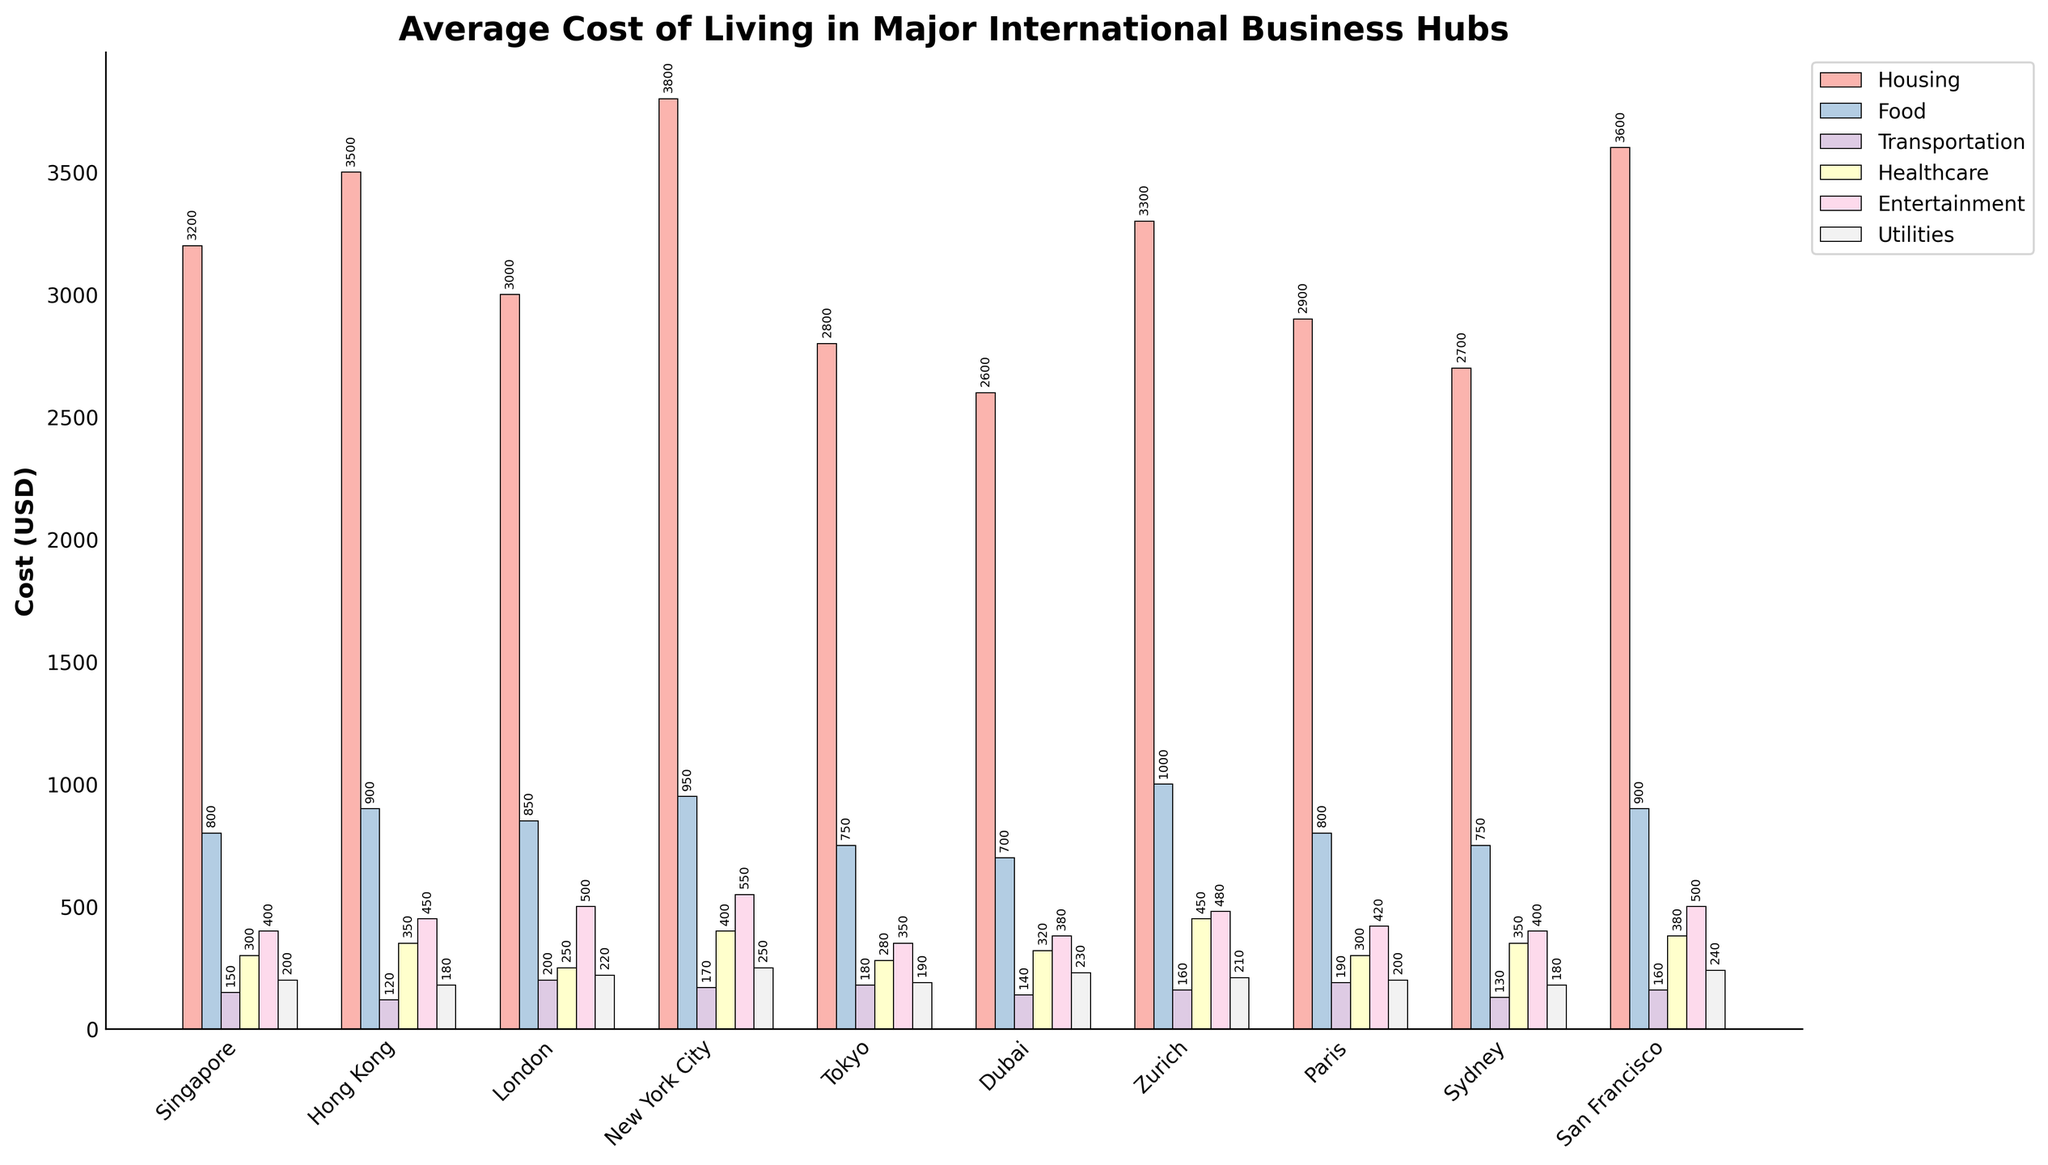Which city has the highest overall cost of living? To find the city with the highest overall cost of living, add up all expense categories for each city and compare the totals. New York City has the highest individual expenses, indicating it likely has the highest overall cost.
Answer: New York City Which two cities have the smallest difference in healthcare costs, and what is the difference? Compare the healthcare costs of all cities to find the smallest difference. Singapore ($300) and Paris ($300) both have the same healthcare cost, resulting in a difference of $0.
Answer: Singapore and Paris; $0 What is the total housing cost for the three most expensive cities in terms of housing? Identify the three cities with the highest housing costs: New York City ($3800), Hong Kong ($3500), San Francisco ($3600). Add these values together: 3800 + 3500 + 3600 = 10900.
Answer: $10900 Which category contributes the most to the cost of living in Zurich? Look at the height of the bars for Zurich. The tallest bar represents Food, indicating it's the most significant contributor.
Answer: Food How much more does healthcare cost in Zurich compared to Dubai? Subtract Dubai's healthcare cost ($320) from Zurich's healthcare cost ($450): 450 - 320 = 130.
Answer: $130 What is the average entertainment cost across all cities? Add up the entertainment costs for all cities and divide by the number of cities: (400 + 450 + 500 + 550 + 350 + 380 + 480 + 420 + 400 + 500) / 10 = 4430 / 10 = 443.
Answer: $443 Which city spends the least on transportation, and by how much is it lower than the city that spends the most? Find the city with the lowest transportation cost, which is Dubai ($140), and the highest, which is London ($200). Subtract the lowest from the highest: 200 - 140 = 60.
Answer: Dubai; $60 What is the total cost of utilities in cities where it costs more than $200? Identify the cities where utilities cost more than $200: New York City ($250), London ($220), Dubai ($230), and San Francisco ($240). Add these values: 250 + 220 + 230 + 240 = 940.
Answer: $940 Which city's total transport and entertainment costs are closest to San Francisco's total transport and entertainment costs? Calculate the sum of transport and entertainment costs for each city and compare them. San Francisco: 160 + 500 = 660. Tokyo: 180 + 350 = 530, London: 200 + 500 = 700, etc. The closest total is from London.
Answer: London 